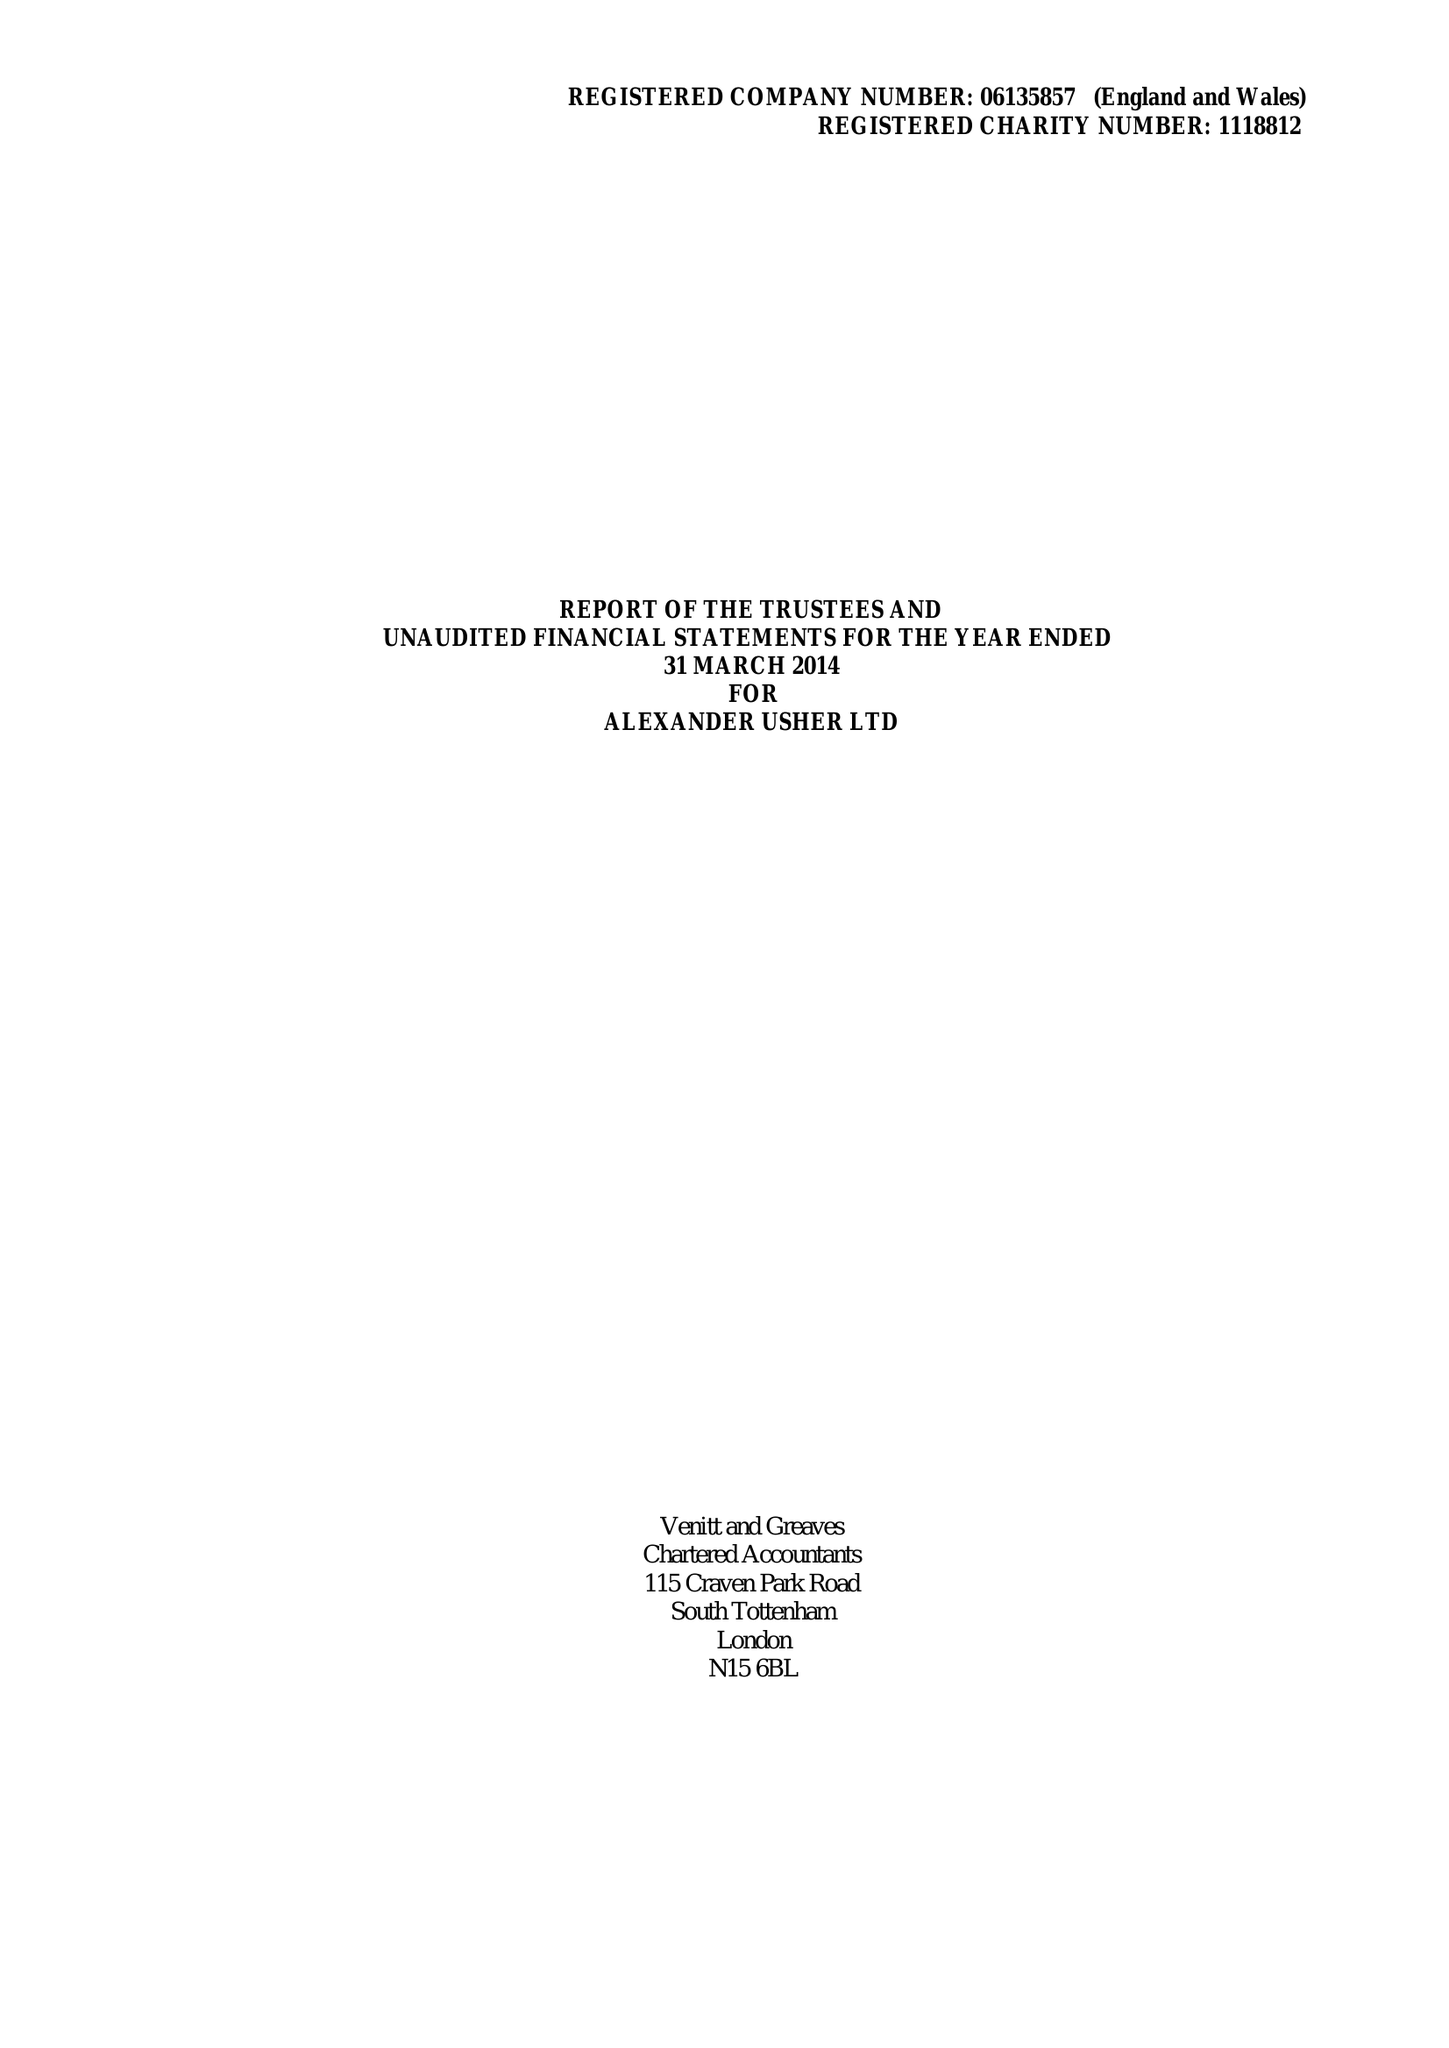What is the value for the charity_number?
Answer the question using a single word or phrase. 1118812 